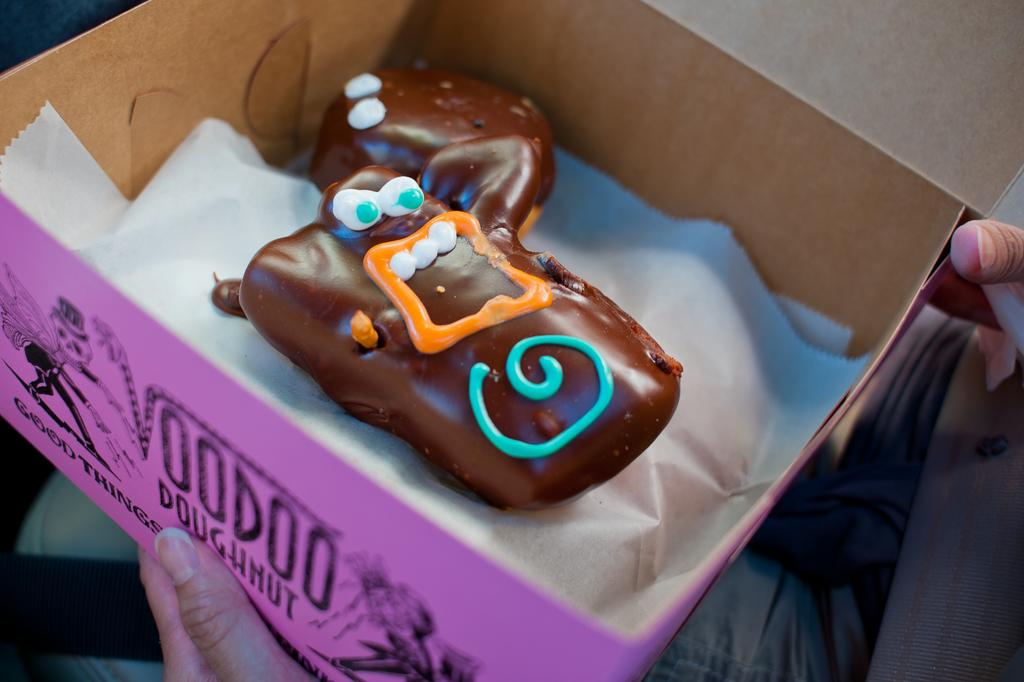What is the main object in the image? There is a food item in the image. What other object is present in the image? There is a paper in the image. Where are the food item and paper located? The food item and paper are in a box. Who is holding the box? The box is being held by a person. What type of throat can be seen in the image? There is no throat present in the image. What happens to the box when it bursts in the image? The box does not burst in the image; it is being held by a person. 